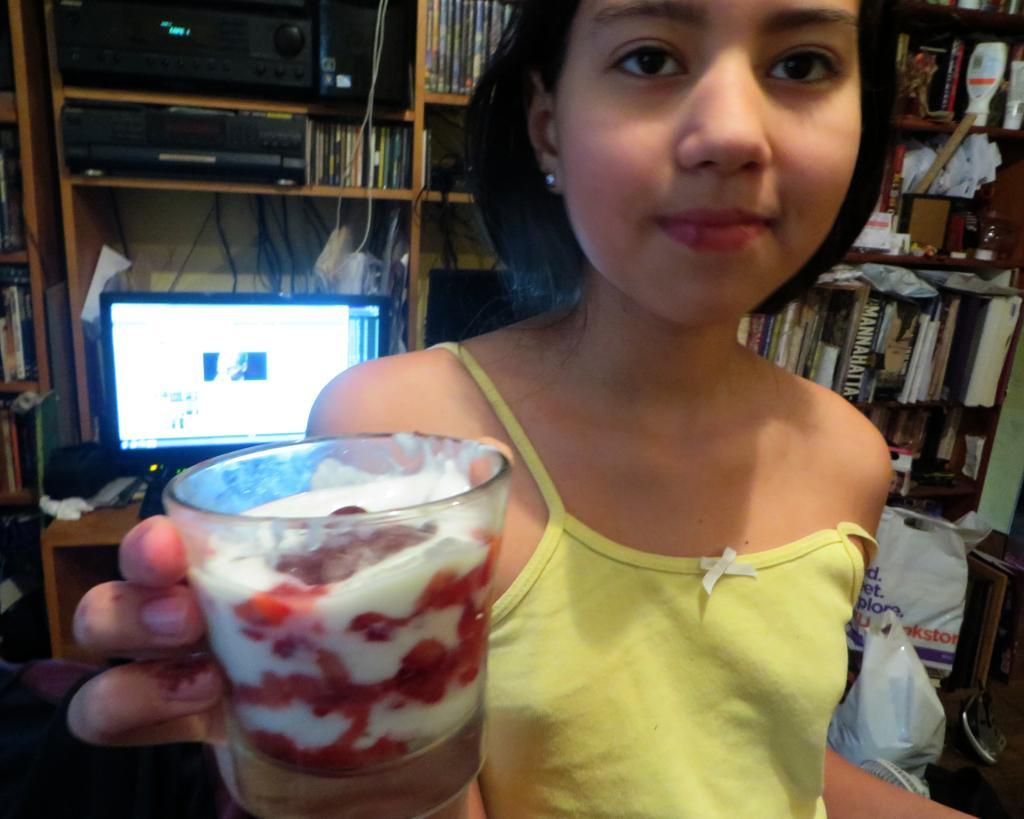Can you describe this image briefly? In this image we can see a girl holding a glass with food. In the background we can see a monitor, table, devices, racks, books, and plastic covers. 